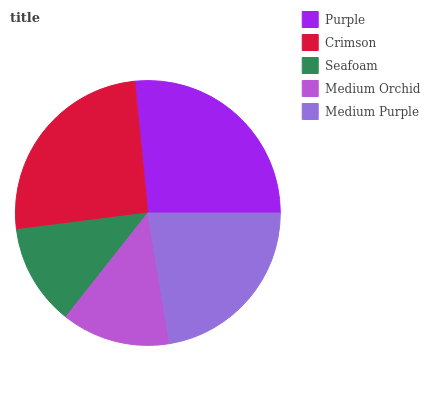Is Seafoam the minimum?
Answer yes or no. Yes. Is Purple the maximum?
Answer yes or no. Yes. Is Crimson the minimum?
Answer yes or no. No. Is Crimson the maximum?
Answer yes or no. No. Is Purple greater than Crimson?
Answer yes or no. Yes. Is Crimson less than Purple?
Answer yes or no. Yes. Is Crimson greater than Purple?
Answer yes or no. No. Is Purple less than Crimson?
Answer yes or no. No. Is Medium Purple the high median?
Answer yes or no. Yes. Is Medium Purple the low median?
Answer yes or no. Yes. Is Crimson the high median?
Answer yes or no. No. Is Seafoam the low median?
Answer yes or no. No. 